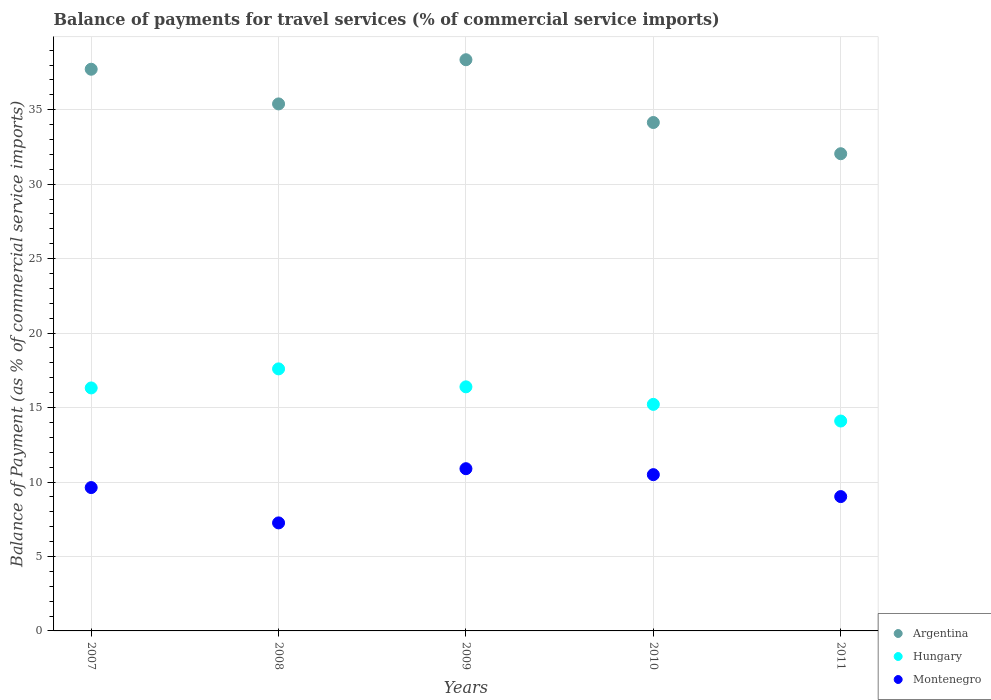How many different coloured dotlines are there?
Your answer should be compact. 3. Is the number of dotlines equal to the number of legend labels?
Offer a terse response. Yes. What is the balance of payments for travel services in Montenegro in 2008?
Make the answer very short. 7.25. Across all years, what is the maximum balance of payments for travel services in Hungary?
Your response must be concise. 17.6. Across all years, what is the minimum balance of payments for travel services in Argentina?
Ensure brevity in your answer.  32.04. In which year was the balance of payments for travel services in Argentina maximum?
Keep it short and to the point. 2009. In which year was the balance of payments for travel services in Hungary minimum?
Keep it short and to the point. 2011. What is the total balance of payments for travel services in Montenegro in the graph?
Your answer should be compact. 47.29. What is the difference between the balance of payments for travel services in Argentina in 2008 and that in 2010?
Give a very brief answer. 1.25. What is the difference between the balance of payments for travel services in Hungary in 2007 and the balance of payments for travel services in Argentina in 2010?
Your response must be concise. -17.82. What is the average balance of payments for travel services in Montenegro per year?
Give a very brief answer. 9.46. In the year 2007, what is the difference between the balance of payments for travel services in Argentina and balance of payments for travel services in Hungary?
Make the answer very short. 21.4. In how many years, is the balance of payments for travel services in Hungary greater than 37 %?
Make the answer very short. 0. What is the ratio of the balance of payments for travel services in Hungary in 2007 to that in 2010?
Offer a terse response. 1.07. Is the balance of payments for travel services in Hungary in 2007 less than that in 2011?
Your answer should be very brief. No. What is the difference between the highest and the second highest balance of payments for travel services in Hungary?
Give a very brief answer. 1.21. What is the difference between the highest and the lowest balance of payments for travel services in Montenegro?
Your response must be concise. 3.64. In how many years, is the balance of payments for travel services in Montenegro greater than the average balance of payments for travel services in Montenegro taken over all years?
Ensure brevity in your answer.  3. Does the balance of payments for travel services in Argentina monotonically increase over the years?
Make the answer very short. No. Are the values on the major ticks of Y-axis written in scientific E-notation?
Keep it short and to the point. No. How are the legend labels stacked?
Make the answer very short. Vertical. What is the title of the graph?
Keep it short and to the point. Balance of payments for travel services (% of commercial service imports). Does "Pakistan" appear as one of the legend labels in the graph?
Your answer should be compact. No. What is the label or title of the Y-axis?
Your answer should be compact. Balance of Payment (as % of commercial service imports). What is the Balance of Payment (as % of commercial service imports) of Argentina in 2007?
Provide a succinct answer. 37.72. What is the Balance of Payment (as % of commercial service imports) of Hungary in 2007?
Make the answer very short. 16.32. What is the Balance of Payment (as % of commercial service imports) of Montenegro in 2007?
Offer a terse response. 9.63. What is the Balance of Payment (as % of commercial service imports) in Argentina in 2008?
Your answer should be very brief. 35.39. What is the Balance of Payment (as % of commercial service imports) in Hungary in 2008?
Offer a terse response. 17.6. What is the Balance of Payment (as % of commercial service imports) of Montenegro in 2008?
Provide a succinct answer. 7.25. What is the Balance of Payment (as % of commercial service imports) in Argentina in 2009?
Your response must be concise. 38.36. What is the Balance of Payment (as % of commercial service imports) of Hungary in 2009?
Your answer should be compact. 16.39. What is the Balance of Payment (as % of commercial service imports) of Montenegro in 2009?
Offer a terse response. 10.89. What is the Balance of Payment (as % of commercial service imports) in Argentina in 2010?
Your response must be concise. 34.14. What is the Balance of Payment (as % of commercial service imports) of Hungary in 2010?
Your answer should be very brief. 15.21. What is the Balance of Payment (as % of commercial service imports) of Montenegro in 2010?
Offer a terse response. 10.49. What is the Balance of Payment (as % of commercial service imports) of Argentina in 2011?
Offer a very short reply. 32.04. What is the Balance of Payment (as % of commercial service imports) of Hungary in 2011?
Ensure brevity in your answer.  14.09. What is the Balance of Payment (as % of commercial service imports) in Montenegro in 2011?
Provide a short and direct response. 9.02. Across all years, what is the maximum Balance of Payment (as % of commercial service imports) in Argentina?
Your answer should be compact. 38.36. Across all years, what is the maximum Balance of Payment (as % of commercial service imports) in Hungary?
Your answer should be very brief. 17.6. Across all years, what is the maximum Balance of Payment (as % of commercial service imports) in Montenegro?
Ensure brevity in your answer.  10.89. Across all years, what is the minimum Balance of Payment (as % of commercial service imports) of Argentina?
Provide a short and direct response. 32.04. Across all years, what is the minimum Balance of Payment (as % of commercial service imports) of Hungary?
Ensure brevity in your answer.  14.09. Across all years, what is the minimum Balance of Payment (as % of commercial service imports) in Montenegro?
Keep it short and to the point. 7.25. What is the total Balance of Payment (as % of commercial service imports) in Argentina in the graph?
Your answer should be compact. 177.65. What is the total Balance of Payment (as % of commercial service imports) of Hungary in the graph?
Keep it short and to the point. 79.61. What is the total Balance of Payment (as % of commercial service imports) in Montenegro in the graph?
Provide a short and direct response. 47.29. What is the difference between the Balance of Payment (as % of commercial service imports) of Argentina in 2007 and that in 2008?
Provide a short and direct response. 2.33. What is the difference between the Balance of Payment (as % of commercial service imports) of Hungary in 2007 and that in 2008?
Your answer should be compact. -1.28. What is the difference between the Balance of Payment (as % of commercial service imports) in Montenegro in 2007 and that in 2008?
Offer a terse response. 2.37. What is the difference between the Balance of Payment (as % of commercial service imports) of Argentina in 2007 and that in 2009?
Make the answer very short. -0.64. What is the difference between the Balance of Payment (as % of commercial service imports) in Hungary in 2007 and that in 2009?
Keep it short and to the point. -0.07. What is the difference between the Balance of Payment (as % of commercial service imports) in Montenegro in 2007 and that in 2009?
Keep it short and to the point. -1.27. What is the difference between the Balance of Payment (as % of commercial service imports) of Argentina in 2007 and that in 2010?
Provide a succinct answer. 3.58. What is the difference between the Balance of Payment (as % of commercial service imports) in Hungary in 2007 and that in 2010?
Offer a terse response. 1.1. What is the difference between the Balance of Payment (as % of commercial service imports) of Montenegro in 2007 and that in 2010?
Offer a terse response. -0.87. What is the difference between the Balance of Payment (as % of commercial service imports) of Argentina in 2007 and that in 2011?
Your answer should be very brief. 5.67. What is the difference between the Balance of Payment (as % of commercial service imports) in Hungary in 2007 and that in 2011?
Make the answer very short. 2.22. What is the difference between the Balance of Payment (as % of commercial service imports) of Montenegro in 2007 and that in 2011?
Your response must be concise. 0.61. What is the difference between the Balance of Payment (as % of commercial service imports) in Argentina in 2008 and that in 2009?
Make the answer very short. -2.97. What is the difference between the Balance of Payment (as % of commercial service imports) of Hungary in 2008 and that in 2009?
Keep it short and to the point. 1.21. What is the difference between the Balance of Payment (as % of commercial service imports) of Montenegro in 2008 and that in 2009?
Your answer should be very brief. -3.64. What is the difference between the Balance of Payment (as % of commercial service imports) of Argentina in 2008 and that in 2010?
Your answer should be very brief. 1.25. What is the difference between the Balance of Payment (as % of commercial service imports) in Hungary in 2008 and that in 2010?
Your answer should be compact. 2.38. What is the difference between the Balance of Payment (as % of commercial service imports) of Montenegro in 2008 and that in 2010?
Provide a short and direct response. -3.24. What is the difference between the Balance of Payment (as % of commercial service imports) of Argentina in 2008 and that in 2011?
Your response must be concise. 3.34. What is the difference between the Balance of Payment (as % of commercial service imports) of Hungary in 2008 and that in 2011?
Make the answer very short. 3.5. What is the difference between the Balance of Payment (as % of commercial service imports) of Montenegro in 2008 and that in 2011?
Keep it short and to the point. -1.77. What is the difference between the Balance of Payment (as % of commercial service imports) in Argentina in 2009 and that in 2010?
Offer a terse response. 4.22. What is the difference between the Balance of Payment (as % of commercial service imports) in Hungary in 2009 and that in 2010?
Your response must be concise. 1.18. What is the difference between the Balance of Payment (as % of commercial service imports) in Montenegro in 2009 and that in 2010?
Your response must be concise. 0.4. What is the difference between the Balance of Payment (as % of commercial service imports) of Argentina in 2009 and that in 2011?
Offer a terse response. 6.31. What is the difference between the Balance of Payment (as % of commercial service imports) of Hungary in 2009 and that in 2011?
Keep it short and to the point. 2.3. What is the difference between the Balance of Payment (as % of commercial service imports) in Montenegro in 2009 and that in 2011?
Give a very brief answer. 1.87. What is the difference between the Balance of Payment (as % of commercial service imports) in Argentina in 2010 and that in 2011?
Give a very brief answer. 2.1. What is the difference between the Balance of Payment (as % of commercial service imports) in Hungary in 2010 and that in 2011?
Keep it short and to the point. 1.12. What is the difference between the Balance of Payment (as % of commercial service imports) of Montenegro in 2010 and that in 2011?
Your answer should be very brief. 1.47. What is the difference between the Balance of Payment (as % of commercial service imports) in Argentina in 2007 and the Balance of Payment (as % of commercial service imports) in Hungary in 2008?
Provide a short and direct response. 20.12. What is the difference between the Balance of Payment (as % of commercial service imports) in Argentina in 2007 and the Balance of Payment (as % of commercial service imports) in Montenegro in 2008?
Keep it short and to the point. 30.46. What is the difference between the Balance of Payment (as % of commercial service imports) in Hungary in 2007 and the Balance of Payment (as % of commercial service imports) in Montenegro in 2008?
Provide a succinct answer. 9.06. What is the difference between the Balance of Payment (as % of commercial service imports) of Argentina in 2007 and the Balance of Payment (as % of commercial service imports) of Hungary in 2009?
Your answer should be very brief. 21.33. What is the difference between the Balance of Payment (as % of commercial service imports) in Argentina in 2007 and the Balance of Payment (as % of commercial service imports) in Montenegro in 2009?
Your answer should be compact. 26.82. What is the difference between the Balance of Payment (as % of commercial service imports) of Hungary in 2007 and the Balance of Payment (as % of commercial service imports) of Montenegro in 2009?
Your response must be concise. 5.42. What is the difference between the Balance of Payment (as % of commercial service imports) in Argentina in 2007 and the Balance of Payment (as % of commercial service imports) in Hungary in 2010?
Give a very brief answer. 22.5. What is the difference between the Balance of Payment (as % of commercial service imports) in Argentina in 2007 and the Balance of Payment (as % of commercial service imports) in Montenegro in 2010?
Provide a short and direct response. 27.22. What is the difference between the Balance of Payment (as % of commercial service imports) in Hungary in 2007 and the Balance of Payment (as % of commercial service imports) in Montenegro in 2010?
Keep it short and to the point. 5.82. What is the difference between the Balance of Payment (as % of commercial service imports) of Argentina in 2007 and the Balance of Payment (as % of commercial service imports) of Hungary in 2011?
Offer a terse response. 23.62. What is the difference between the Balance of Payment (as % of commercial service imports) of Argentina in 2007 and the Balance of Payment (as % of commercial service imports) of Montenegro in 2011?
Make the answer very short. 28.7. What is the difference between the Balance of Payment (as % of commercial service imports) in Hungary in 2007 and the Balance of Payment (as % of commercial service imports) in Montenegro in 2011?
Provide a short and direct response. 7.3. What is the difference between the Balance of Payment (as % of commercial service imports) in Argentina in 2008 and the Balance of Payment (as % of commercial service imports) in Hungary in 2009?
Offer a very short reply. 19. What is the difference between the Balance of Payment (as % of commercial service imports) in Argentina in 2008 and the Balance of Payment (as % of commercial service imports) in Montenegro in 2009?
Your answer should be compact. 24.5. What is the difference between the Balance of Payment (as % of commercial service imports) in Hungary in 2008 and the Balance of Payment (as % of commercial service imports) in Montenegro in 2009?
Your answer should be very brief. 6.7. What is the difference between the Balance of Payment (as % of commercial service imports) of Argentina in 2008 and the Balance of Payment (as % of commercial service imports) of Hungary in 2010?
Provide a succinct answer. 20.18. What is the difference between the Balance of Payment (as % of commercial service imports) in Argentina in 2008 and the Balance of Payment (as % of commercial service imports) in Montenegro in 2010?
Make the answer very short. 24.9. What is the difference between the Balance of Payment (as % of commercial service imports) of Hungary in 2008 and the Balance of Payment (as % of commercial service imports) of Montenegro in 2010?
Ensure brevity in your answer.  7.1. What is the difference between the Balance of Payment (as % of commercial service imports) of Argentina in 2008 and the Balance of Payment (as % of commercial service imports) of Hungary in 2011?
Provide a succinct answer. 21.29. What is the difference between the Balance of Payment (as % of commercial service imports) in Argentina in 2008 and the Balance of Payment (as % of commercial service imports) in Montenegro in 2011?
Make the answer very short. 26.37. What is the difference between the Balance of Payment (as % of commercial service imports) of Hungary in 2008 and the Balance of Payment (as % of commercial service imports) of Montenegro in 2011?
Your answer should be very brief. 8.58. What is the difference between the Balance of Payment (as % of commercial service imports) in Argentina in 2009 and the Balance of Payment (as % of commercial service imports) in Hungary in 2010?
Give a very brief answer. 23.14. What is the difference between the Balance of Payment (as % of commercial service imports) of Argentina in 2009 and the Balance of Payment (as % of commercial service imports) of Montenegro in 2010?
Provide a succinct answer. 27.86. What is the difference between the Balance of Payment (as % of commercial service imports) of Hungary in 2009 and the Balance of Payment (as % of commercial service imports) of Montenegro in 2010?
Your answer should be very brief. 5.9. What is the difference between the Balance of Payment (as % of commercial service imports) in Argentina in 2009 and the Balance of Payment (as % of commercial service imports) in Hungary in 2011?
Make the answer very short. 24.26. What is the difference between the Balance of Payment (as % of commercial service imports) in Argentina in 2009 and the Balance of Payment (as % of commercial service imports) in Montenegro in 2011?
Provide a succinct answer. 29.34. What is the difference between the Balance of Payment (as % of commercial service imports) of Hungary in 2009 and the Balance of Payment (as % of commercial service imports) of Montenegro in 2011?
Give a very brief answer. 7.37. What is the difference between the Balance of Payment (as % of commercial service imports) in Argentina in 2010 and the Balance of Payment (as % of commercial service imports) in Hungary in 2011?
Ensure brevity in your answer.  20.05. What is the difference between the Balance of Payment (as % of commercial service imports) in Argentina in 2010 and the Balance of Payment (as % of commercial service imports) in Montenegro in 2011?
Provide a succinct answer. 25.12. What is the difference between the Balance of Payment (as % of commercial service imports) in Hungary in 2010 and the Balance of Payment (as % of commercial service imports) in Montenegro in 2011?
Your answer should be compact. 6.19. What is the average Balance of Payment (as % of commercial service imports) in Argentina per year?
Your answer should be compact. 35.53. What is the average Balance of Payment (as % of commercial service imports) of Hungary per year?
Offer a terse response. 15.92. What is the average Balance of Payment (as % of commercial service imports) of Montenegro per year?
Provide a succinct answer. 9.46. In the year 2007, what is the difference between the Balance of Payment (as % of commercial service imports) of Argentina and Balance of Payment (as % of commercial service imports) of Hungary?
Your answer should be compact. 21.4. In the year 2007, what is the difference between the Balance of Payment (as % of commercial service imports) in Argentina and Balance of Payment (as % of commercial service imports) in Montenegro?
Offer a terse response. 28.09. In the year 2007, what is the difference between the Balance of Payment (as % of commercial service imports) of Hungary and Balance of Payment (as % of commercial service imports) of Montenegro?
Offer a terse response. 6.69. In the year 2008, what is the difference between the Balance of Payment (as % of commercial service imports) of Argentina and Balance of Payment (as % of commercial service imports) of Hungary?
Give a very brief answer. 17.79. In the year 2008, what is the difference between the Balance of Payment (as % of commercial service imports) of Argentina and Balance of Payment (as % of commercial service imports) of Montenegro?
Ensure brevity in your answer.  28.14. In the year 2008, what is the difference between the Balance of Payment (as % of commercial service imports) in Hungary and Balance of Payment (as % of commercial service imports) in Montenegro?
Offer a terse response. 10.34. In the year 2009, what is the difference between the Balance of Payment (as % of commercial service imports) in Argentina and Balance of Payment (as % of commercial service imports) in Hungary?
Provide a short and direct response. 21.97. In the year 2009, what is the difference between the Balance of Payment (as % of commercial service imports) in Argentina and Balance of Payment (as % of commercial service imports) in Montenegro?
Offer a very short reply. 27.46. In the year 2009, what is the difference between the Balance of Payment (as % of commercial service imports) of Hungary and Balance of Payment (as % of commercial service imports) of Montenegro?
Offer a terse response. 5.5. In the year 2010, what is the difference between the Balance of Payment (as % of commercial service imports) of Argentina and Balance of Payment (as % of commercial service imports) of Hungary?
Your response must be concise. 18.93. In the year 2010, what is the difference between the Balance of Payment (as % of commercial service imports) of Argentina and Balance of Payment (as % of commercial service imports) of Montenegro?
Make the answer very short. 23.65. In the year 2010, what is the difference between the Balance of Payment (as % of commercial service imports) in Hungary and Balance of Payment (as % of commercial service imports) in Montenegro?
Your response must be concise. 4.72. In the year 2011, what is the difference between the Balance of Payment (as % of commercial service imports) of Argentina and Balance of Payment (as % of commercial service imports) of Hungary?
Offer a terse response. 17.95. In the year 2011, what is the difference between the Balance of Payment (as % of commercial service imports) of Argentina and Balance of Payment (as % of commercial service imports) of Montenegro?
Keep it short and to the point. 23.02. In the year 2011, what is the difference between the Balance of Payment (as % of commercial service imports) of Hungary and Balance of Payment (as % of commercial service imports) of Montenegro?
Offer a very short reply. 5.07. What is the ratio of the Balance of Payment (as % of commercial service imports) of Argentina in 2007 to that in 2008?
Give a very brief answer. 1.07. What is the ratio of the Balance of Payment (as % of commercial service imports) in Hungary in 2007 to that in 2008?
Give a very brief answer. 0.93. What is the ratio of the Balance of Payment (as % of commercial service imports) of Montenegro in 2007 to that in 2008?
Ensure brevity in your answer.  1.33. What is the ratio of the Balance of Payment (as % of commercial service imports) of Argentina in 2007 to that in 2009?
Offer a terse response. 0.98. What is the ratio of the Balance of Payment (as % of commercial service imports) of Montenegro in 2007 to that in 2009?
Your response must be concise. 0.88. What is the ratio of the Balance of Payment (as % of commercial service imports) in Argentina in 2007 to that in 2010?
Keep it short and to the point. 1.1. What is the ratio of the Balance of Payment (as % of commercial service imports) in Hungary in 2007 to that in 2010?
Offer a terse response. 1.07. What is the ratio of the Balance of Payment (as % of commercial service imports) of Montenegro in 2007 to that in 2010?
Offer a terse response. 0.92. What is the ratio of the Balance of Payment (as % of commercial service imports) of Argentina in 2007 to that in 2011?
Provide a succinct answer. 1.18. What is the ratio of the Balance of Payment (as % of commercial service imports) of Hungary in 2007 to that in 2011?
Provide a succinct answer. 1.16. What is the ratio of the Balance of Payment (as % of commercial service imports) of Montenegro in 2007 to that in 2011?
Offer a terse response. 1.07. What is the ratio of the Balance of Payment (as % of commercial service imports) in Argentina in 2008 to that in 2009?
Provide a short and direct response. 0.92. What is the ratio of the Balance of Payment (as % of commercial service imports) of Hungary in 2008 to that in 2009?
Provide a succinct answer. 1.07. What is the ratio of the Balance of Payment (as % of commercial service imports) of Montenegro in 2008 to that in 2009?
Provide a short and direct response. 0.67. What is the ratio of the Balance of Payment (as % of commercial service imports) of Argentina in 2008 to that in 2010?
Keep it short and to the point. 1.04. What is the ratio of the Balance of Payment (as % of commercial service imports) in Hungary in 2008 to that in 2010?
Your answer should be very brief. 1.16. What is the ratio of the Balance of Payment (as % of commercial service imports) of Montenegro in 2008 to that in 2010?
Your response must be concise. 0.69. What is the ratio of the Balance of Payment (as % of commercial service imports) in Argentina in 2008 to that in 2011?
Offer a terse response. 1.1. What is the ratio of the Balance of Payment (as % of commercial service imports) in Hungary in 2008 to that in 2011?
Your answer should be very brief. 1.25. What is the ratio of the Balance of Payment (as % of commercial service imports) of Montenegro in 2008 to that in 2011?
Make the answer very short. 0.8. What is the ratio of the Balance of Payment (as % of commercial service imports) in Argentina in 2009 to that in 2010?
Your answer should be very brief. 1.12. What is the ratio of the Balance of Payment (as % of commercial service imports) of Hungary in 2009 to that in 2010?
Offer a very short reply. 1.08. What is the ratio of the Balance of Payment (as % of commercial service imports) of Montenegro in 2009 to that in 2010?
Offer a very short reply. 1.04. What is the ratio of the Balance of Payment (as % of commercial service imports) in Argentina in 2009 to that in 2011?
Your answer should be compact. 1.2. What is the ratio of the Balance of Payment (as % of commercial service imports) in Hungary in 2009 to that in 2011?
Offer a terse response. 1.16. What is the ratio of the Balance of Payment (as % of commercial service imports) of Montenegro in 2009 to that in 2011?
Your answer should be very brief. 1.21. What is the ratio of the Balance of Payment (as % of commercial service imports) of Argentina in 2010 to that in 2011?
Your response must be concise. 1.07. What is the ratio of the Balance of Payment (as % of commercial service imports) of Hungary in 2010 to that in 2011?
Ensure brevity in your answer.  1.08. What is the ratio of the Balance of Payment (as % of commercial service imports) of Montenegro in 2010 to that in 2011?
Your answer should be compact. 1.16. What is the difference between the highest and the second highest Balance of Payment (as % of commercial service imports) in Argentina?
Keep it short and to the point. 0.64. What is the difference between the highest and the second highest Balance of Payment (as % of commercial service imports) of Hungary?
Give a very brief answer. 1.21. What is the difference between the highest and the second highest Balance of Payment (as % of commercial service imports) in Montenegro?
Provide a succinct answer. 0.4. What is the difference between the highest and the lowest Balance of Payment (as % of commercial service imports) in Argentina?
Keep it short and to the point. 6.31. What is the difference between the highest and the lowest Balance of Payment (as % of commercial service imports) of Hungary?
Ensure brevity in your answer.  3.5. What is the difference between the highest and the lowest Balance of Payment (as % of commercial service imports) of Montenegro?
Ensure brevity in your answer.  3.64. 